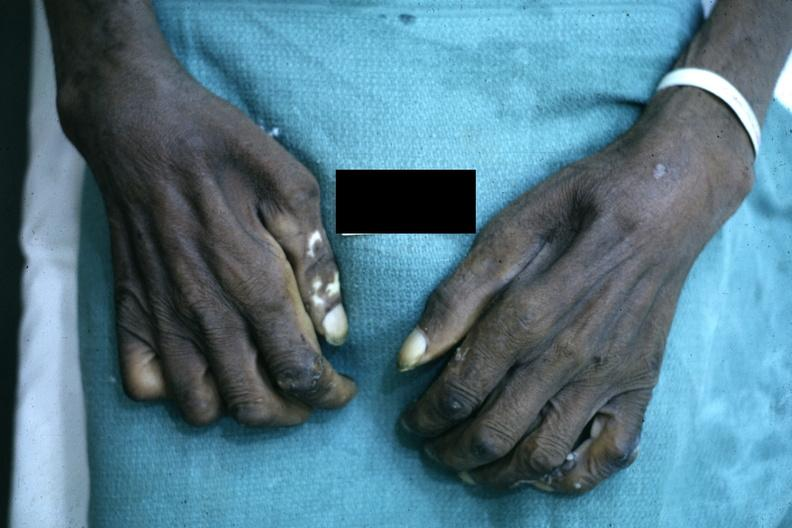what said to be due to syringomyelus?
Answer the question using a single word or phrase. Close-up excellent example of interosseous muscle atrophy 